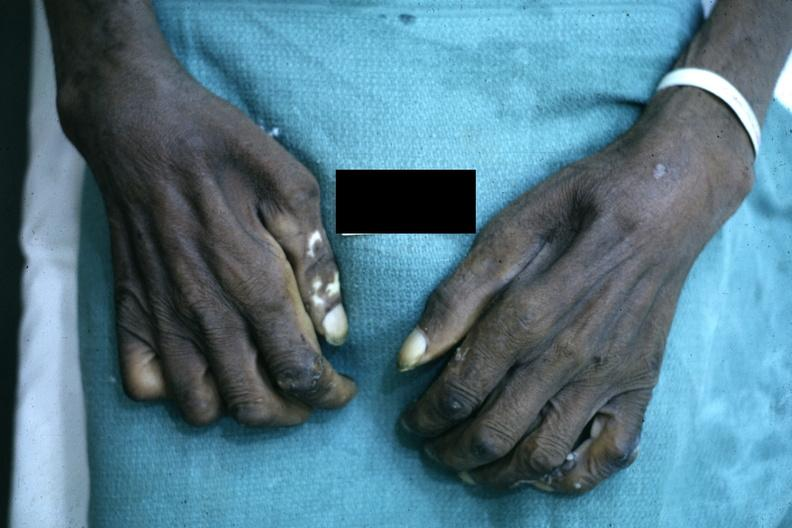what said to be due to syringomyelus?
Answer the question using a single word or phrase. Close-up excellent example of interosseous muscle atrophy 